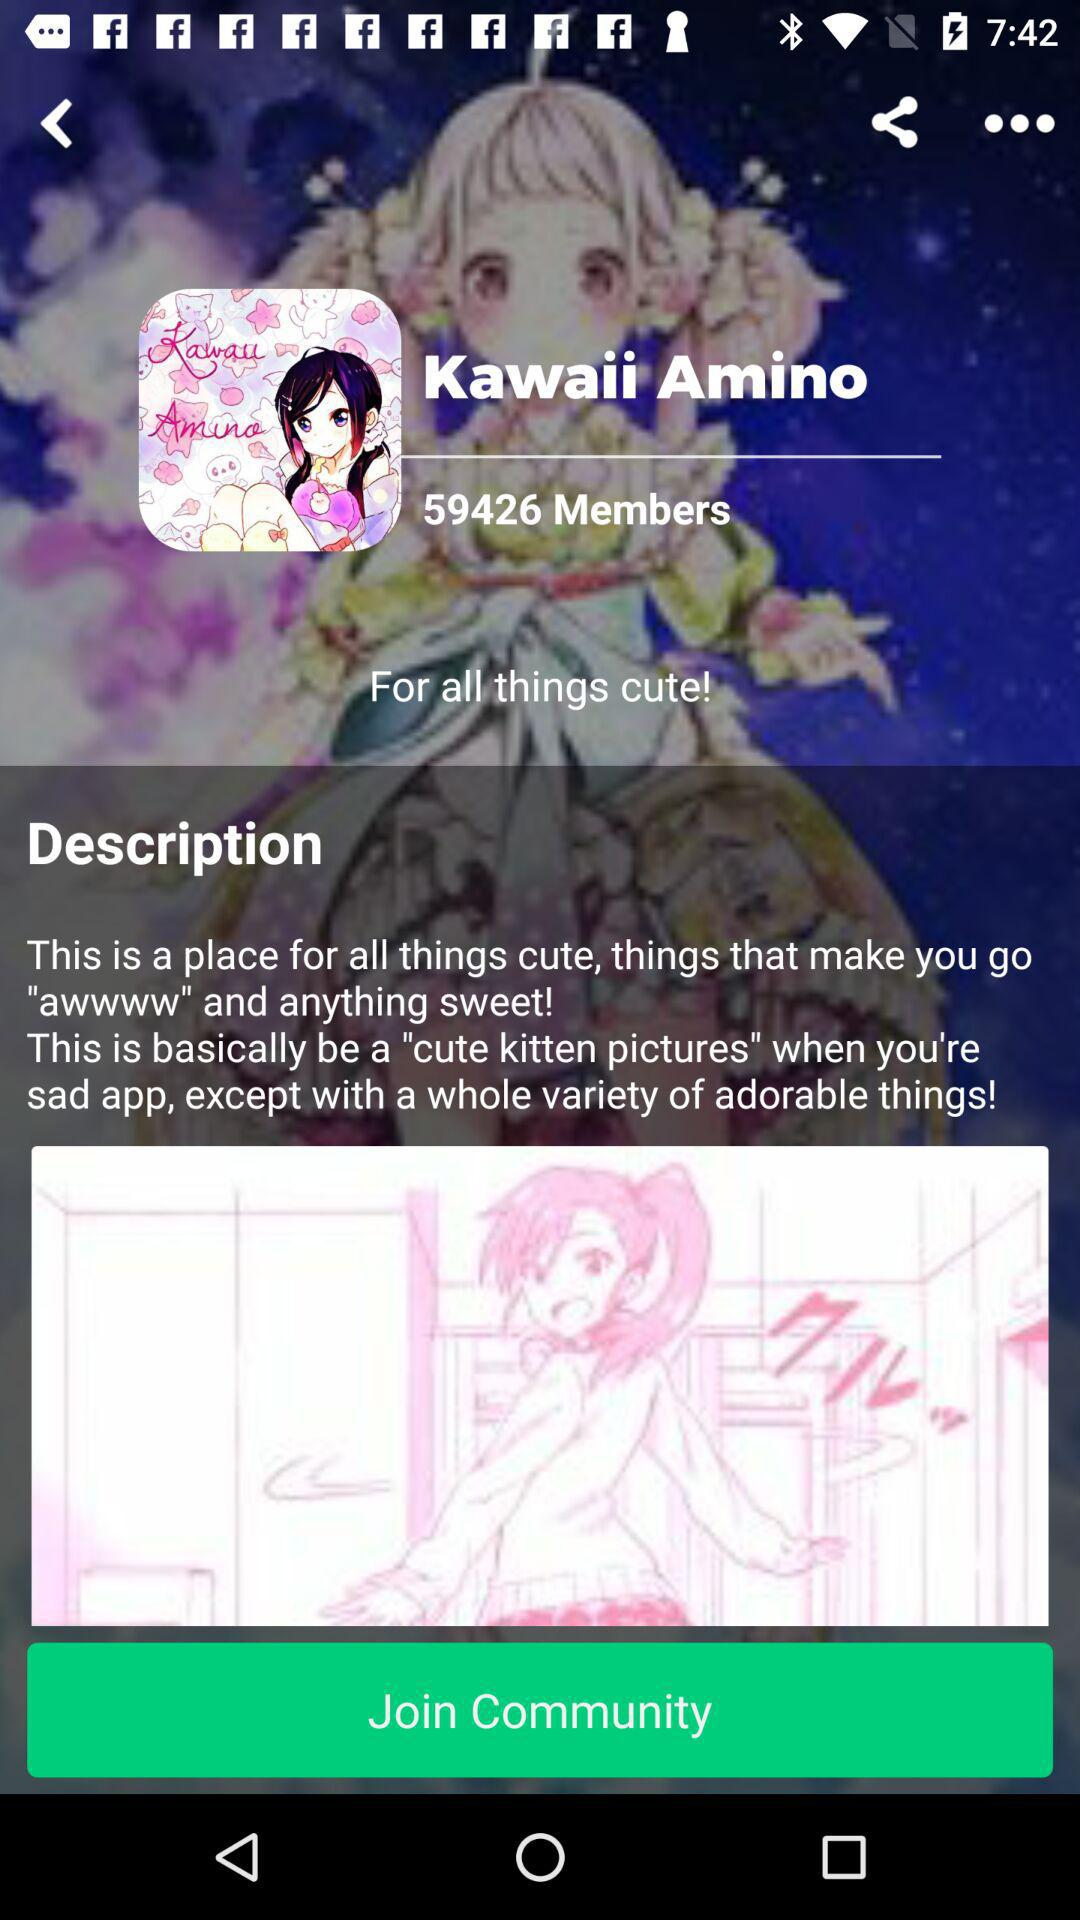What is the name of the community? The name of the community is "Kawaii Amino". 